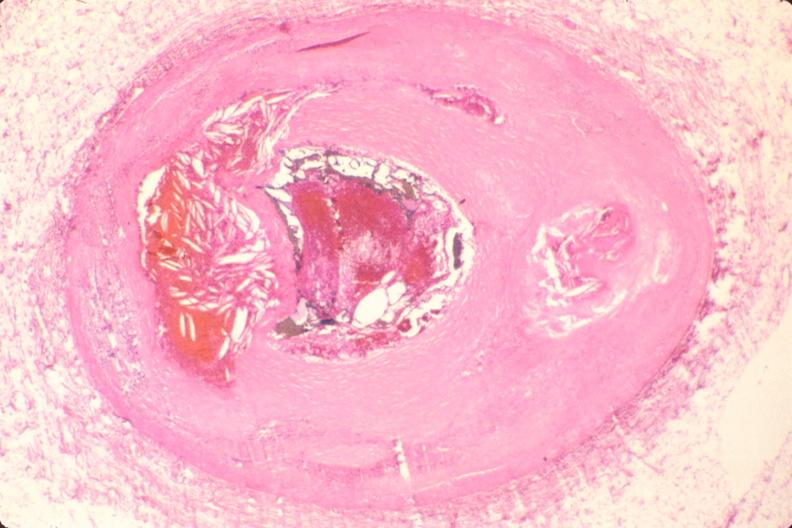what is present?
Answer the question using a single word or phrase. Vasculature 